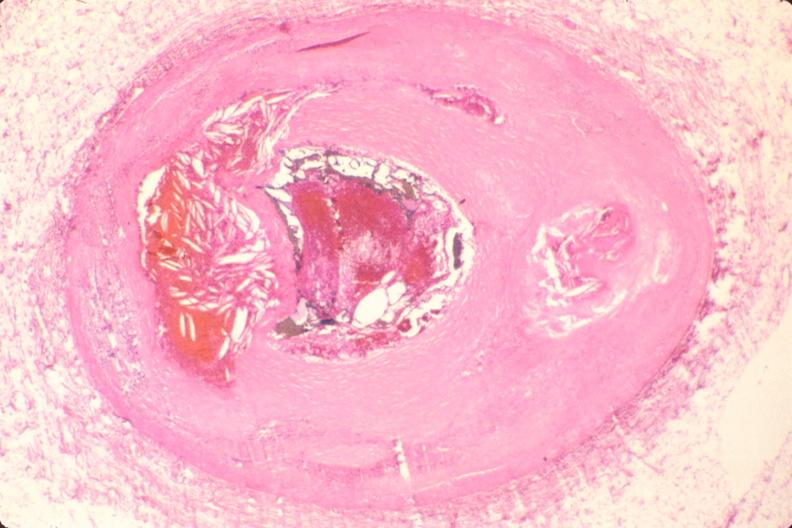what is present?
Answer the question using a single word or phrase. Vasculature 